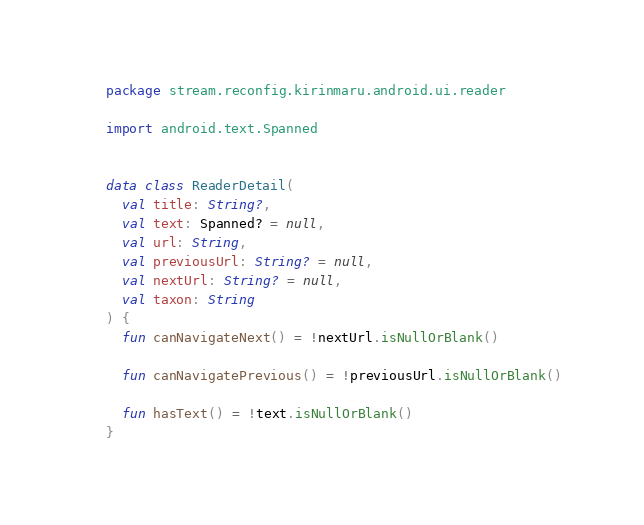<code> <loc_0><loc_0><loc_500><loc_500><_Kotlin_>package stream.reconfig.kirinmaru.android.ui.reader

import android.text.Spanned


data class ReaderDetail(
  val title: String?,
  val text: Spanned? = null,
  val url: String,
  val previousUrl: String? = null,
  val nextUrl: String? = null,
  val taxon: String
) {
  fun canNavigateNext() = !nextUrl.isNullOrBlank()

  fun canNavigatePrevious() = !previousUrl.isNullOrBlank()

  fun hasText() = !text.isNullOrBlank()
}


</code> 